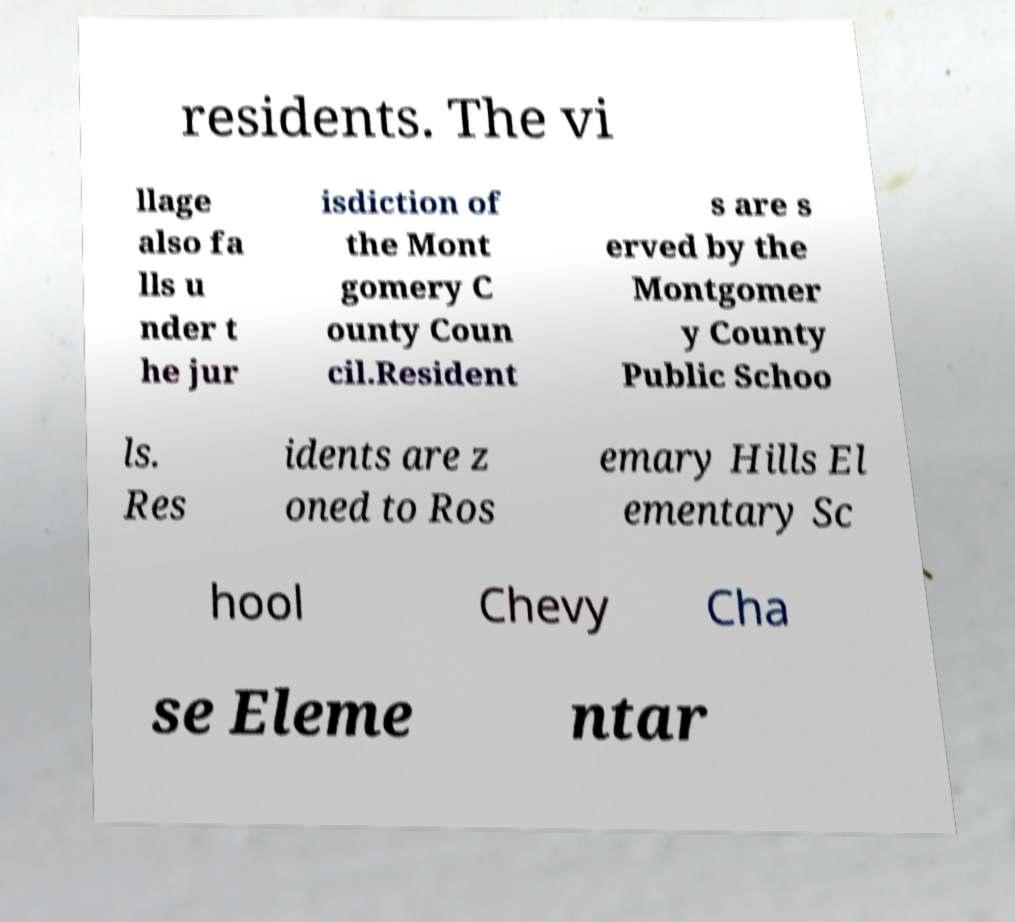There's text embedded in this image that I need extracted. Can you transcribe it verbatim? residents. The vi llage also fa lls u nder t he jur isdiction of the Mont gomery C ounty Coun cil.Resident s are s erved by the Montgomer y County Public Schoo ls. Res idents are z oned to Ros emary Hills El ementary Sc hool Chevy Cha se Eleme ntar 